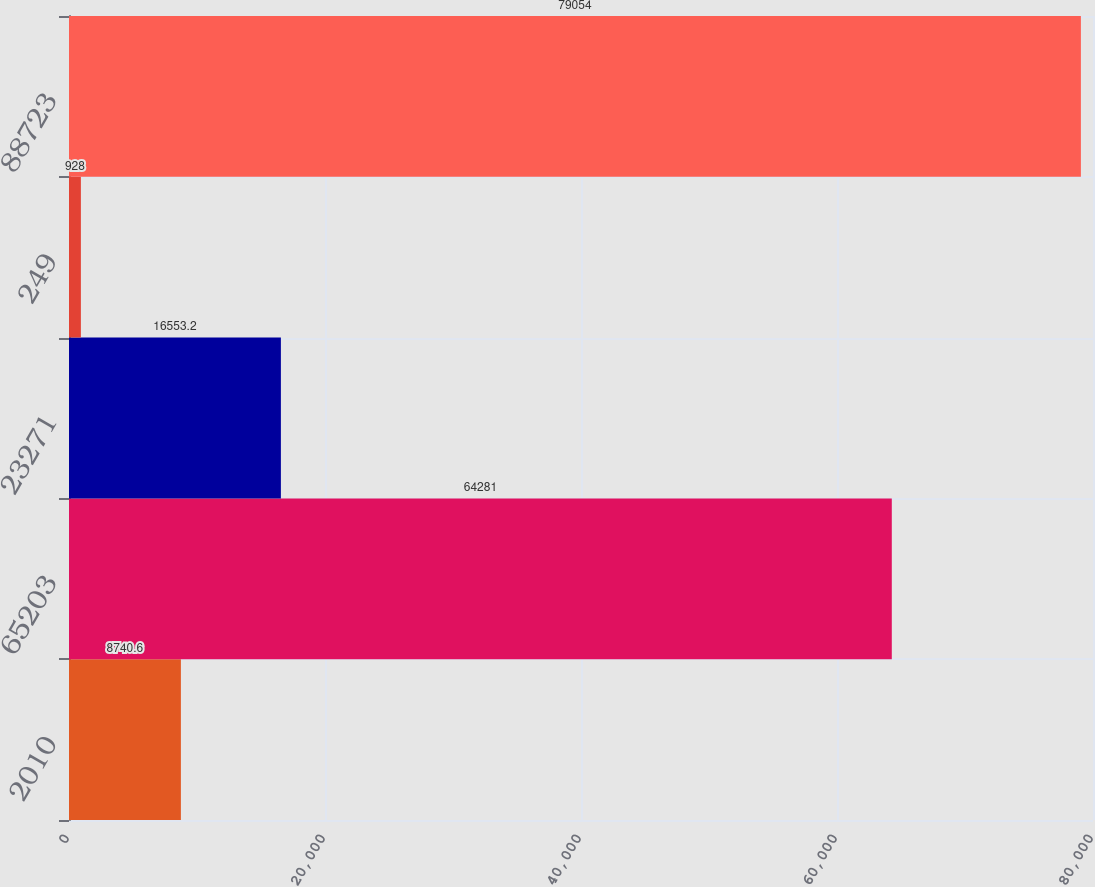<chart> <loc_0><loc_0><loc_500><loc_500><bar_chart><fcel>2010<fcel>65203<fcel>23271<fcel>249<fcel>88723<nl><fcel>8740.6<fcel>64281<fcel>16553.2<fcel>928<fcel>79054<nl></chart> 